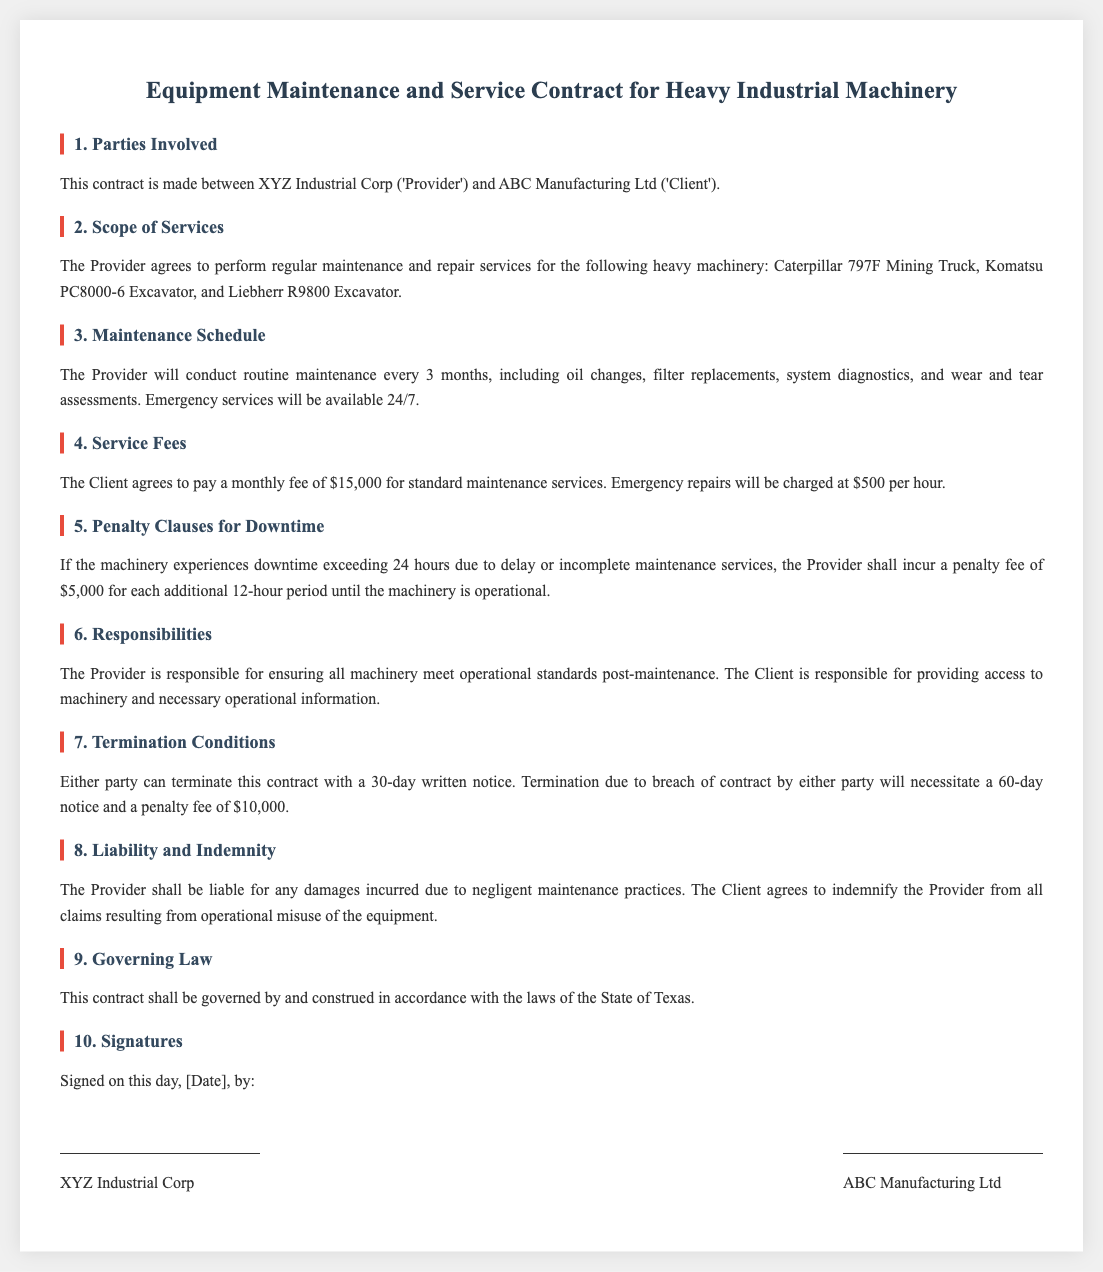What is the name of the Provider? The Provider is referred to as XYZ Industrial Corp in the document.
Answer: XYZ Industrial Corp What is the monthly fee for standard maintenance services? The document states that the Client agrees to pay a monthly fee of $15,000 for standard maintenance services.
Answer: $15,000 How often will routine maintenance be conducted? According to the document, routine maintenance will be conducted every 3 months.
Answer: every 3 months What is the penalty fee for each 12 hours of downtime? The contract specifies a penalty fee of $5,000 for each additional 12-hour period of downtime.
Answer: $5,000 What is the notice period for termination of the contract? The document states that either party can terminate the contract with a 30-day written notice.
Answer: 30 days Who is responsible for operational misuse claims? The Client is responsible for indemnifying the Provider from all claims resulting from operational misuse.
Answer: The Client What should the Provider ensure after maintenance? The Provider is responsible for ensuring all machinery meet operational standards post-maintenance.
Answer: operational standards What is the penalty fee for breach of contract? The contract specifies a penalty fee of $10,000 for breach of contract leading to termination.
Answer: $10,000 Which state's law governs this contract? The contract is governed by the laws of the State of Texas.
Answer: Texas 